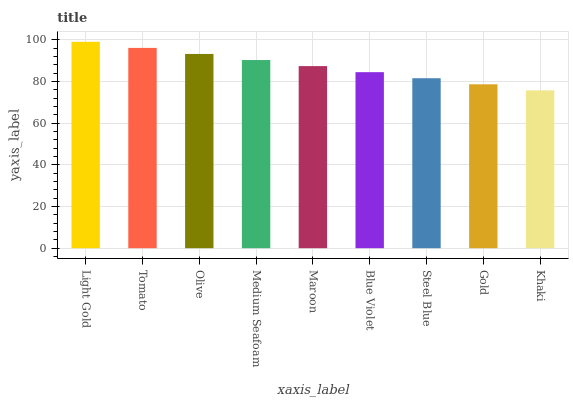Is Khaki the minimum?
Answer yes or no. Yes. Is Light Gold the maximum?
Answer yes or no. Yes. Is Tomato the minimum?
Answer yes or no. No. Is Tomato the maximum?
Answer yes or no. No. Is Light Gold greater than Tomato?
Answer yes or no. Yes. Is Tomato less than Light Gold?
Answer yes or no. Yes. Is Tomato greater than Light Gold?
Answer yes or no. No. Is Light Gold less than Tomato?
Answer yes or no. No. Is Maroon the high median?
Answer yes or no. Yes. Is Maroon the low median?
Answer yes or no. Yes. Is Khaki the high median?
Answer yes or no. No. Is Olive the low median?
Answer yes or no. No. 